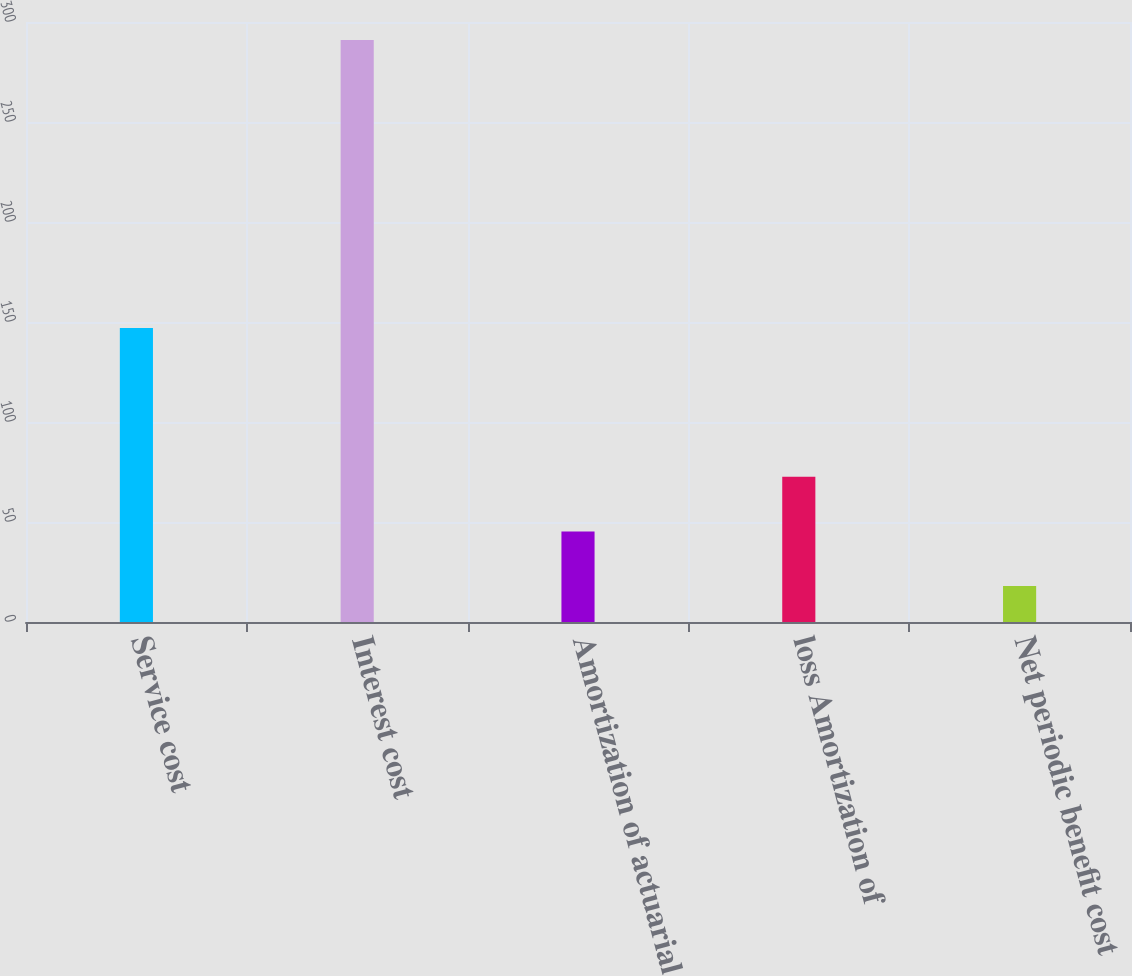<chart> <loc_0><loc_0><loc_500><loc_500><bar_chart><fcel>Service cost<fcel>Interest cost<fcel>Amortization of actuarial<fcel>loss Amortization of<fcel>Net periodic benefit cost<nl><fcel>147<fcel>291<fcel>45.3<fcel>72.6<fcel>18<nl></chart> 